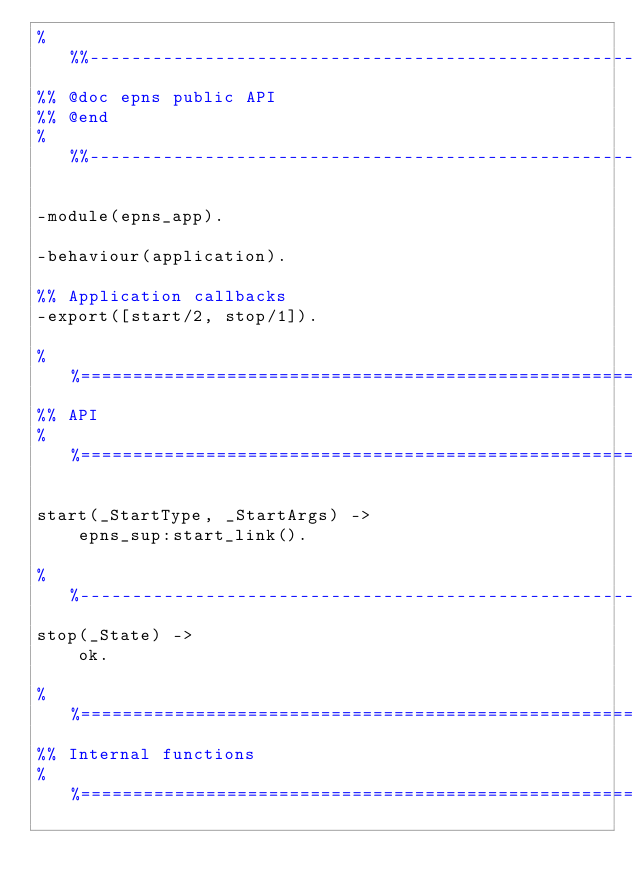Convert code to text. <code><loc_0><loc_0><loc_500><loc_500><_Erlang_>%%%-------------------------------------------------------------------
%% @doc epns public API
%% @end
%%%-------------------------------------------------------------------

-module(epns_app).

-behaviour(application).

%% Application callbacks
-export([start/2, stop/1]).

%%====================================================================
%% API
%%====================================================================

start(_StartType, _StartArgs) ->
    epns_sup:start_link().

%%--------------------------------------------------------------------
stop(_State) ->
    ok.

%%====================================================================
%% Internal functions
%%====================================================================
</code> 